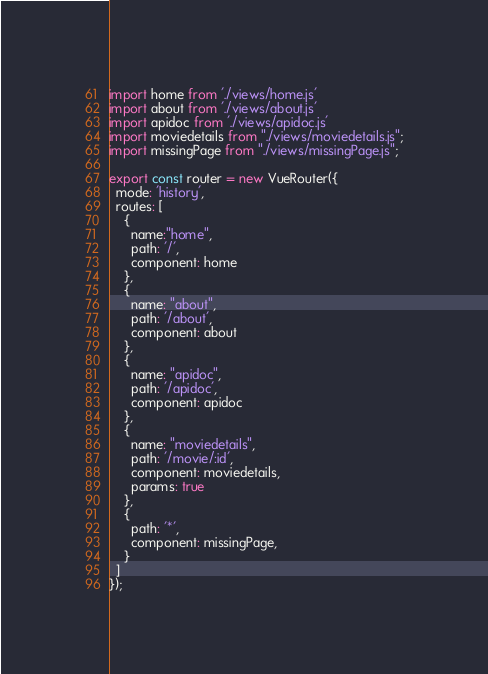Convert code to text. <code><loc_0><loc_0><loc_500><loc_500><_JavaScript_>import home from './views/home.js'
import about from './views/about.js'
import apidoc from './views/apidoc.js'
import moviedetails from "./views/moviedetails.js";
import missingPage from "./views/missingPage.js";

export const router = new VueRouter({
  mode: 'history',
  routes: [
    {
      name:"home",
      path: '/', 
      component: home
    },
    {
      name: "about",
      path: '/about', 
      component: about
    },
    {
      name: "apidoc",
      path: '/apidoc',
      component: apidoc
    },
    {
      name: "moviedetails",
      path: '/movie/:id',
      component: moviedetails,
      params: true
    },
    {
      path: '*',
      component: missingPage,
    }
  ]
});</code> 